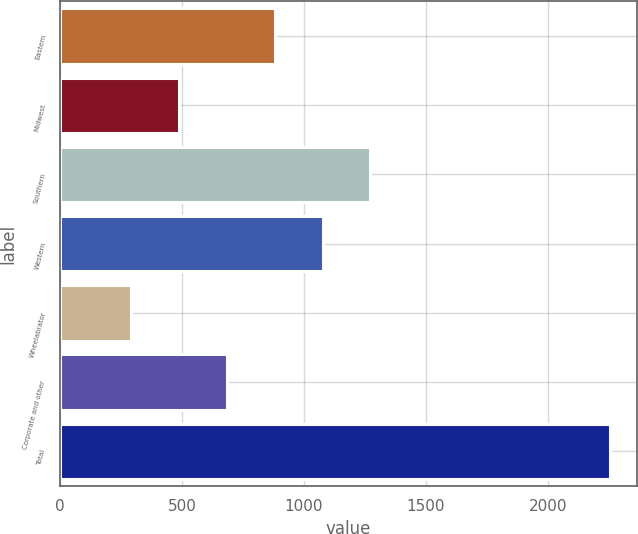Convert chart. <chart><loc_0><loc_0><loc_500><loc_500><bar_chart><fcel>Eastern<fcel>Midwest<fcel>Southern<fcel>Western<fcel>Wheelabrator<fcel>Corporate and other<fcel>Total<nl><fcel>880.6<fcel>488.2<fcel>1273<fcel>1076.8<fcel>292<fcel>684.4<fcel>2254<nl></chart> 